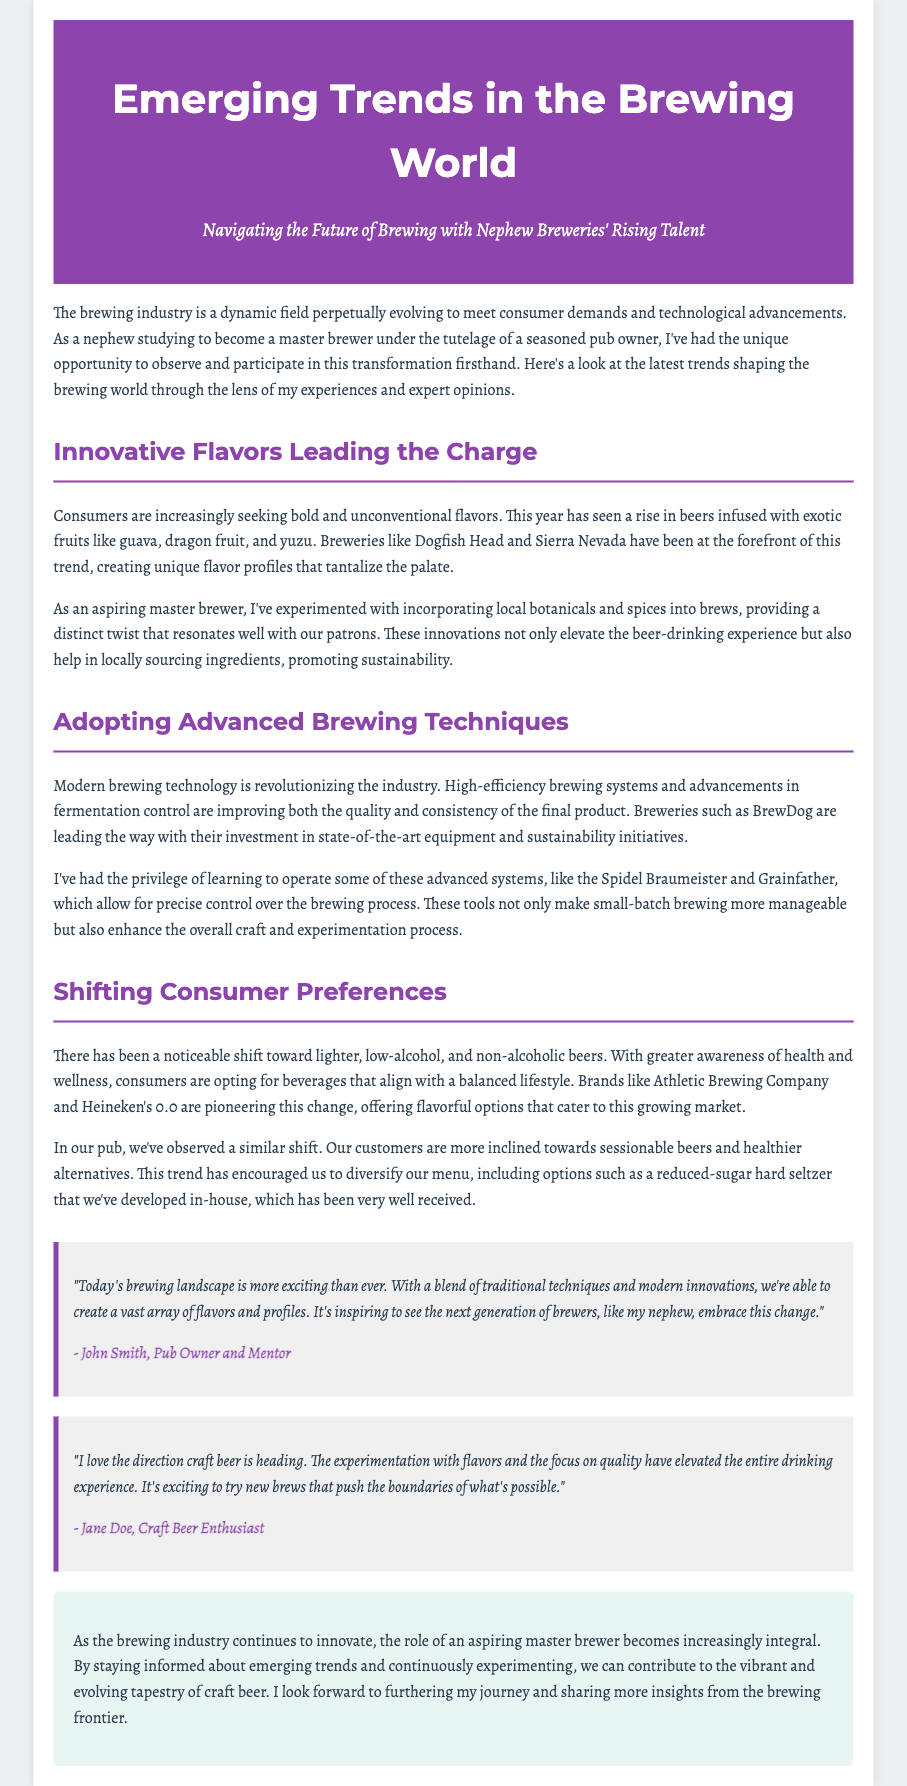what is the title of the press release? The title is prominently displayed at the top of the document, indicating the main subject.
Answer: Emerging Trends in the Brewing World who is the main author or perspective of the document? The document is narrated from the viewpoint of a nephew aspiring to be a master brewer.
Answer: Nephew Brewer which brewery is mentioned as a pioneer in low-alcohol options? The document highlights this brand as a leader in the shift towards low-alcohol beers.
Answer: Athletic Brewing Company what flavor trend is noted as rising in popularity? The document specifies the growing consumer interest in flavorful additions to beers.
Answer: Exotic fruits how does the pub's customer preferences reflect broader consumer trends? The narrative ties consumer trends to the experiences and observations of pub patrons.
Answer: Healthier alternatives what is a notable brewing technology mentioned? The document discusses a modern brewing system that enhances precision in brewing.
Answer: Spidel Braumeister who is quoted in the document as a mentor? This person offers insight into the evolution of the brewing landscape and praises new brewers.
Answer: John Smith what key benefit of advanced brewing techniques is outlined? The text illustrates an improvement that these techniques provide to beer quality and consistency.
Answer: Quality and consistency 